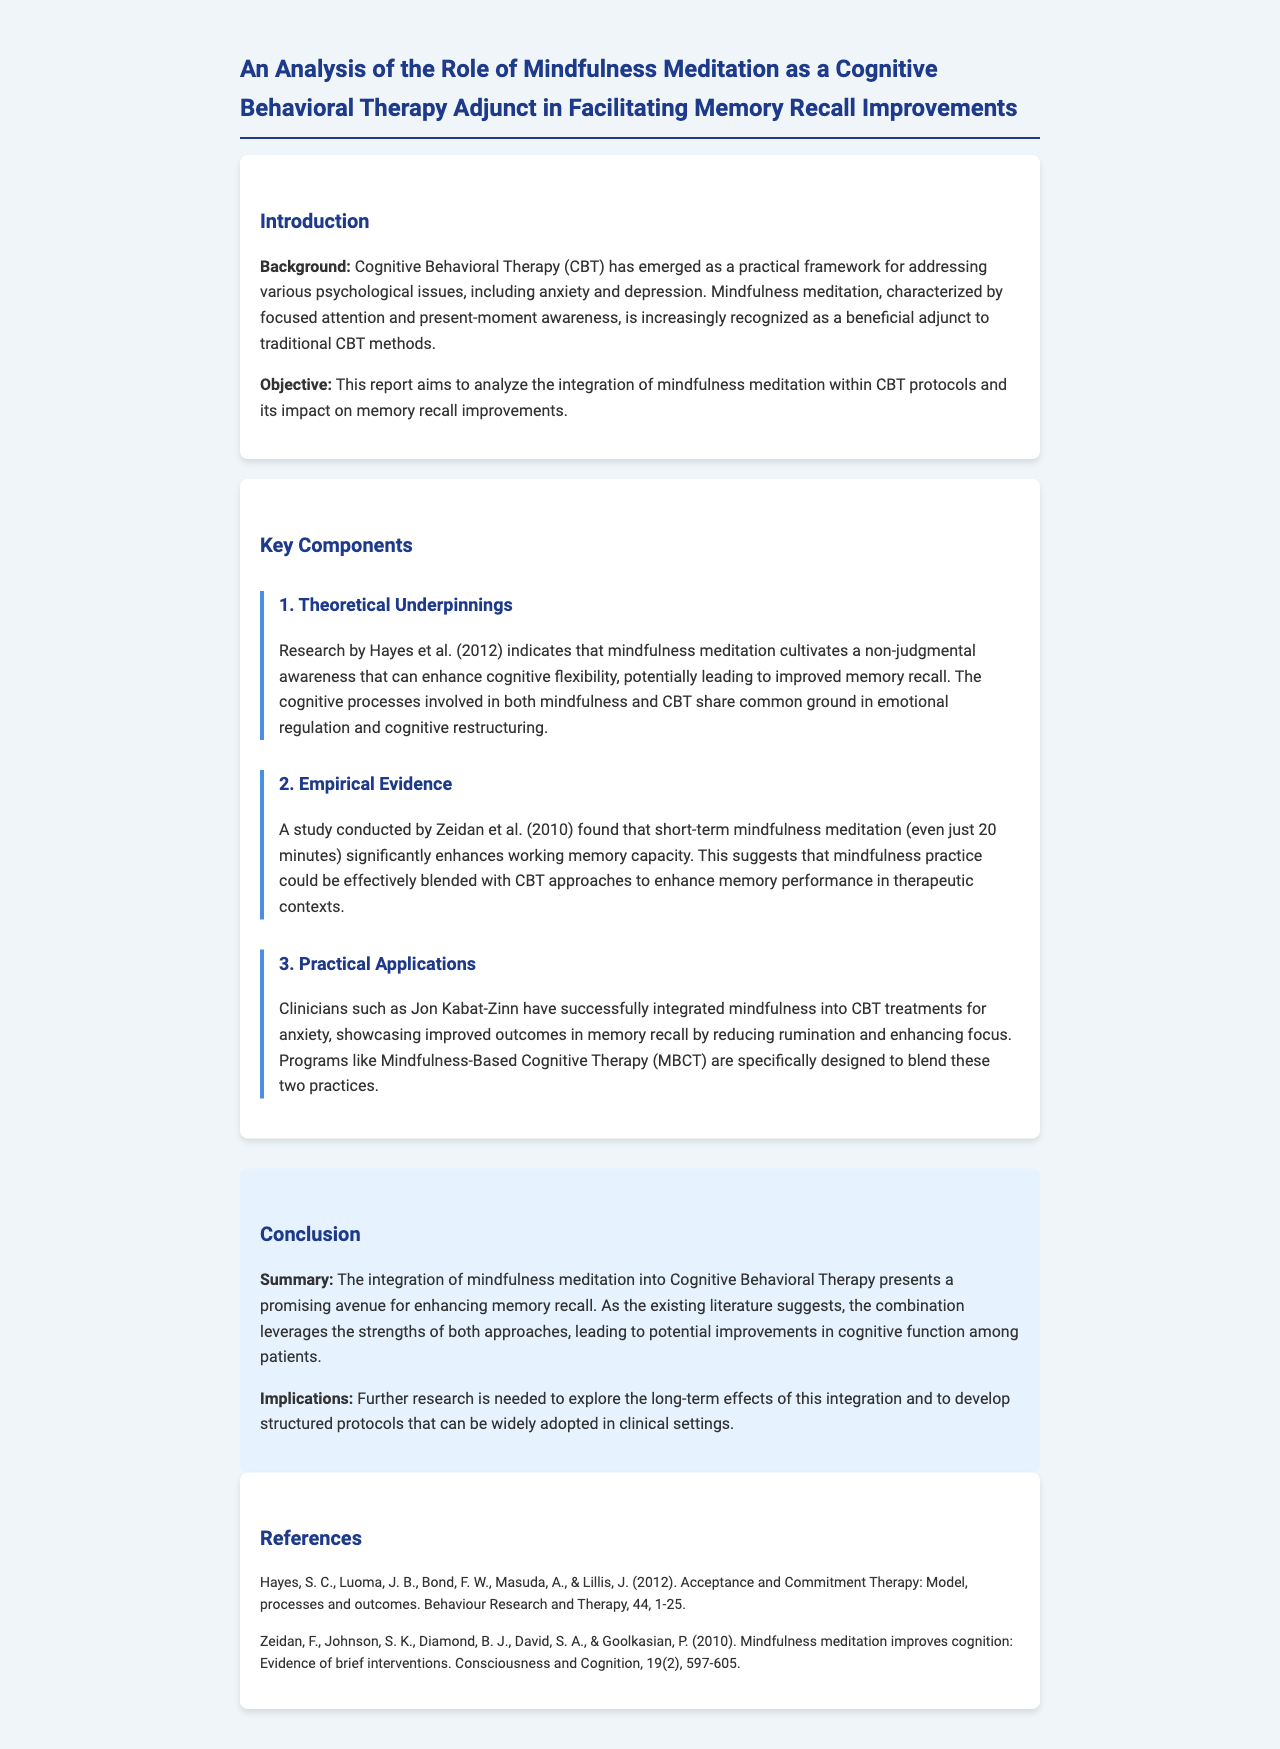what is the title of the report? The title of the report is found at the top of the document.
Answer: An Analysis of the Role of Mindfulness Meditation as a Cognitive Behavioral Therapy Adjunct in Facilitating Memory Recall Improvements who is a prominent clinician mentioned in the document? The document references a specific clinician known for integrating mindfulness into CBT.
Answer: Jon Kabat-Zinn what year did the study by Zeidan et al. occur? This information is provided in the empirical evidence section of the document.
Answer: 2010 what does CBT stand for? The abbreviation is defined in the introduction, clarifying the focus of the report.
Answer: Cognitive Behavioral Therapy what is one reported benefit of mindfulness meditation in the context of CBT? The document provides specific benefits related to memory recall.
Answer: Improved memory recall which program is mentioned that blends mindfulness and CBT? The program referenced in the practical applications section showcases this integration.
Answer: Mindfulness-Based Cognitive Therapy (MBCT) how many authors are listed for the Hayes et al. study? The specific number of authors listed can be found in the references section.
Answer: Five what key concept does mindfulness meditation enhance according to the theoretical underpinnings? The document indicates a particular cognitive ability that mindfulness influences positively.
Answer: Cognitive flexibility what is the publication style of the referenced studies in the report? The format of referencing is consistent throughout, indicating the source details.
Answer: APA style 